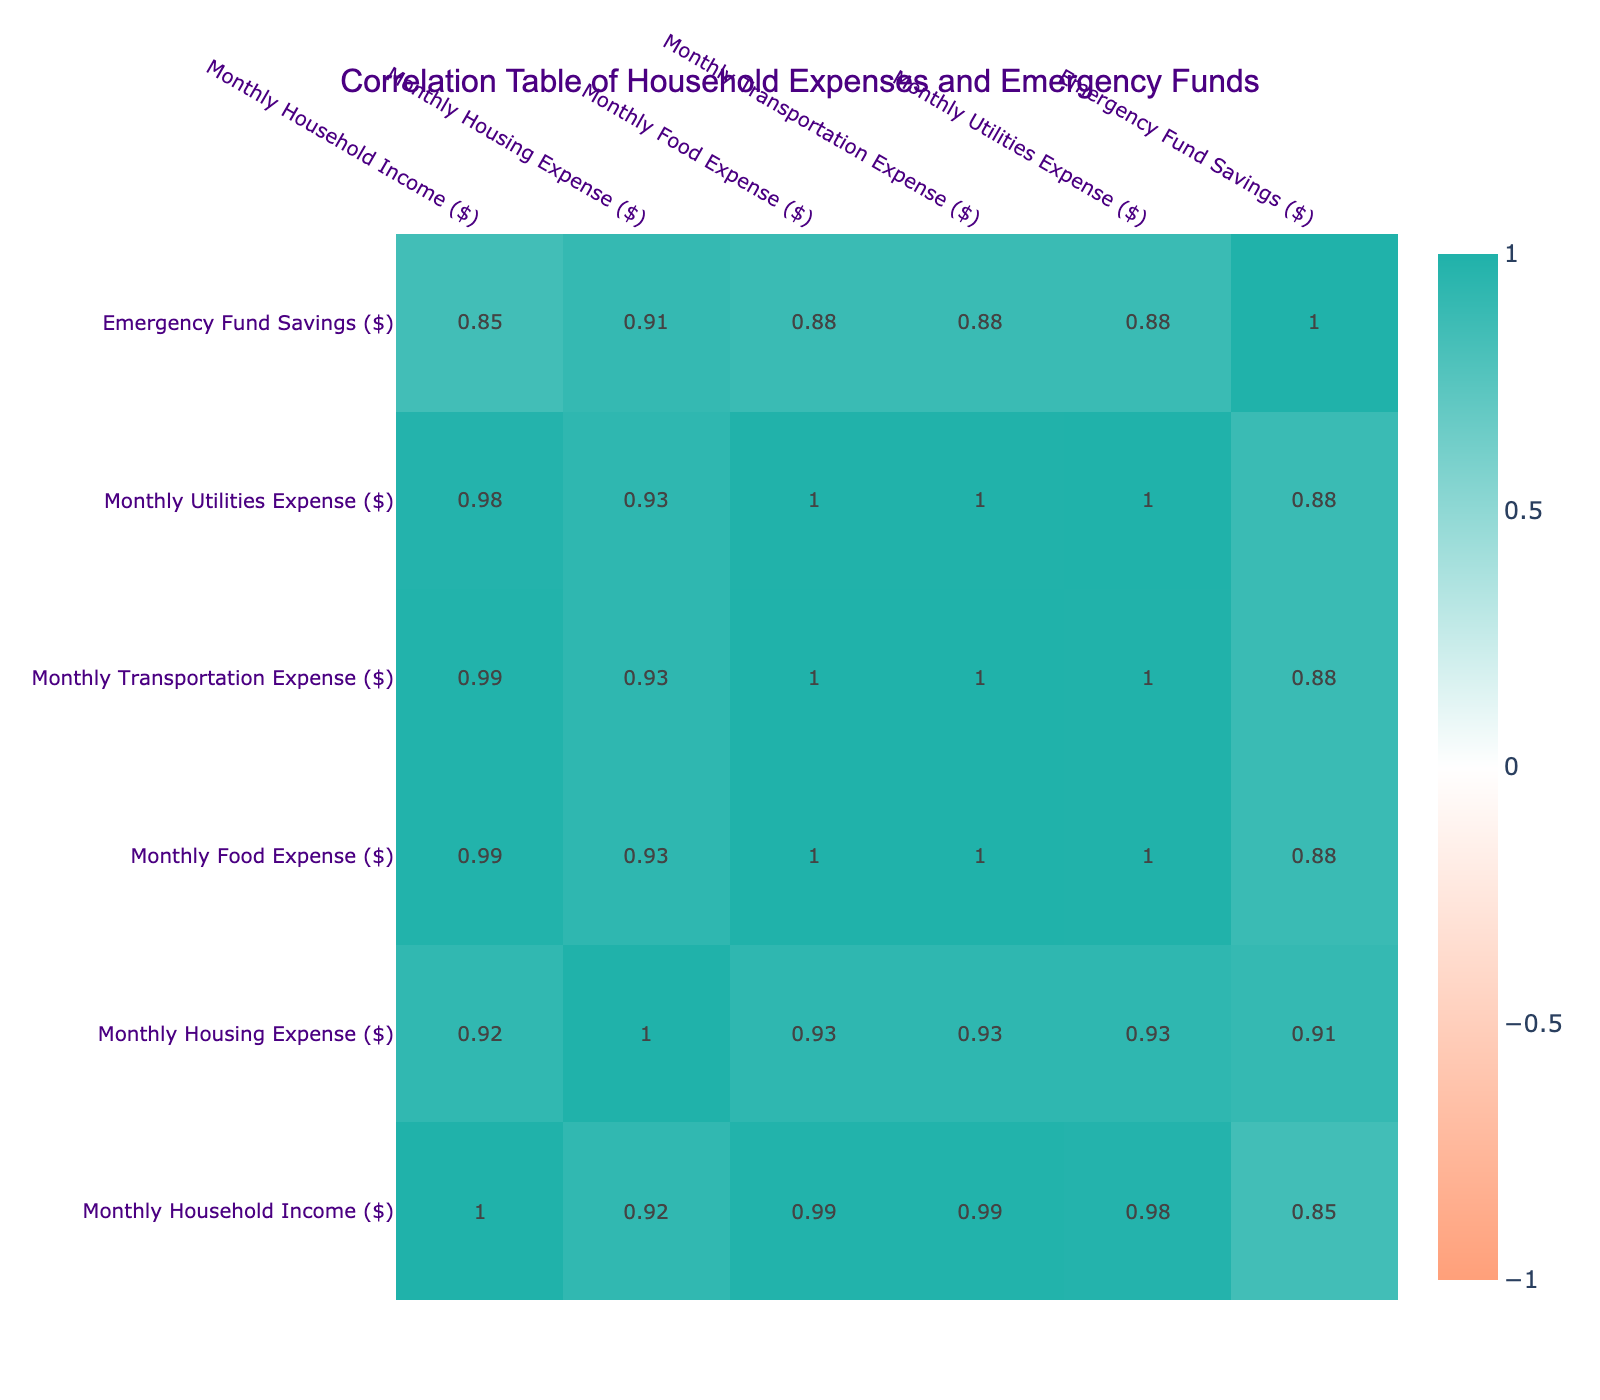What is the highest monthly housing expense among the families? By reviewing the "Monthly Housing Expense" column, we can see that the maximum value is 2100, which corresponds to the Martinez family.
Answer: 2100 What is the total monthly food expense for the Jones and Garcia families? First, locate the values for the food expenses of both families: Jones has a monthly food expense of 550, and Garcia has 750. Then, sum them up: 550 + 750 = 1300.
Answer: 1300 Do the Johnson family have an emergency fund that is less than $5000? Checking the "Emergency Fund Savings" for the Johnson family shows 6000, which is greater than 5000. Thus, the statement is false.
Answer: No How many families have emergency funds over $8000? Checking the "Emergency Fund Savings" column, the families with savings above 8000 are Smith, Garcia, Brown, Rodriguez, and Martinez, which amounts to a total of 5 families.
Answer: 5 What is the average monthly transportation expense of the families in the table? Adding up the transportation expenses (400 + 500 + 450 + 600 + 350 + 550 + 420 + 380 + 500 + 700 = 5000) and dividing by the number of families (10), we get 5000 / 10 = 500.
Answer: 500 Is there a correlation between monthly food expense and emergency fund savings? Observing the correlation table, the correlation coefficient indicates a weak negative correlation of approximately -0.13 between these two variables, suggesting there isn't a strong relationship.
Answer: Yes, weak negative correlation What is the difference in monthly housing expenses between the family with the highest and lowest housing expenses? The Martinez family has the highest housing expense at 2100, while the Jones family has the lowest at 1300. The difference is 2100 - 1300 = 800.
Answer: 800 Which family has the lowest monthly utility expense? By checking the "Monthly Utilities Expense" column, we find that the Jones family has the lowest expense at 180.
Answer: 180 How does the emergency fund of the Brown family compare to the average emergency fund of all families? The average emergency fund can be calculated by summing up all emergency funds (8000 + 6000 + 5000 + 12000 + 4000 + 9000 + 7000 + 3000 + 11000 + 15000 = 80000) and dividing by 10, resulting in 8000. Since the Brown family has 12000, it is higher than average.
Answer: Higher than average 